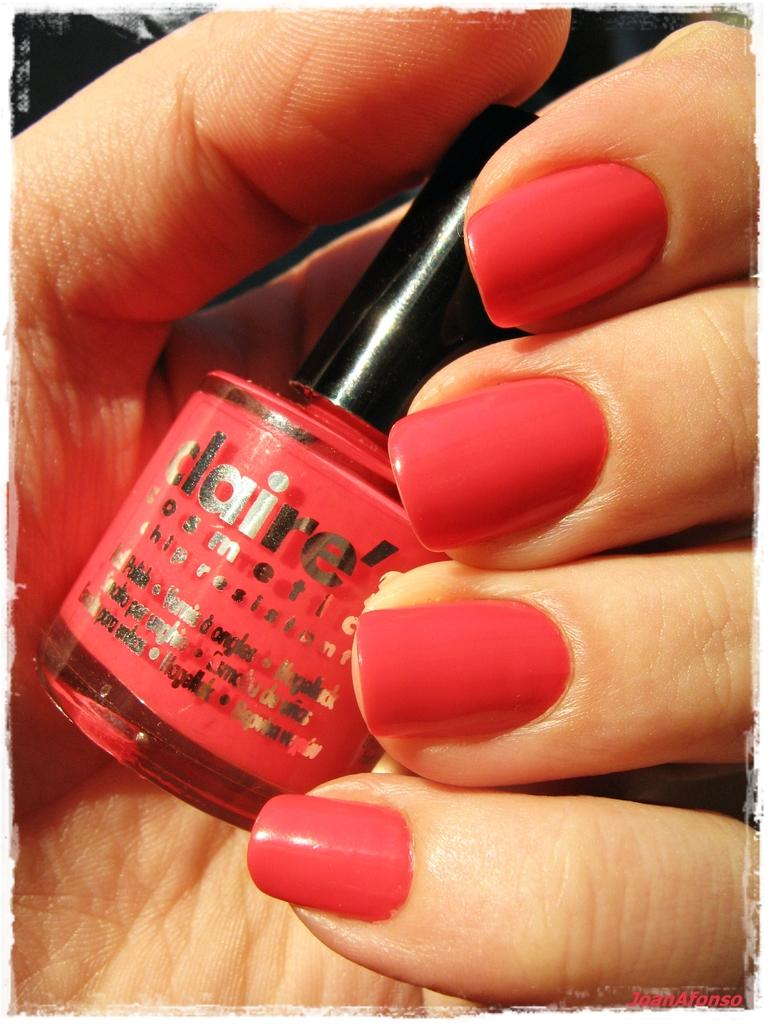What is present in the image that belongs to a person? There is a hand in the image that belongs to a person. What is the person holding in the image? The person is holding a nail polish in the image. What type of hook is the person using to trade their tail in the image? There is no hook, trade, or tail present in the image. 